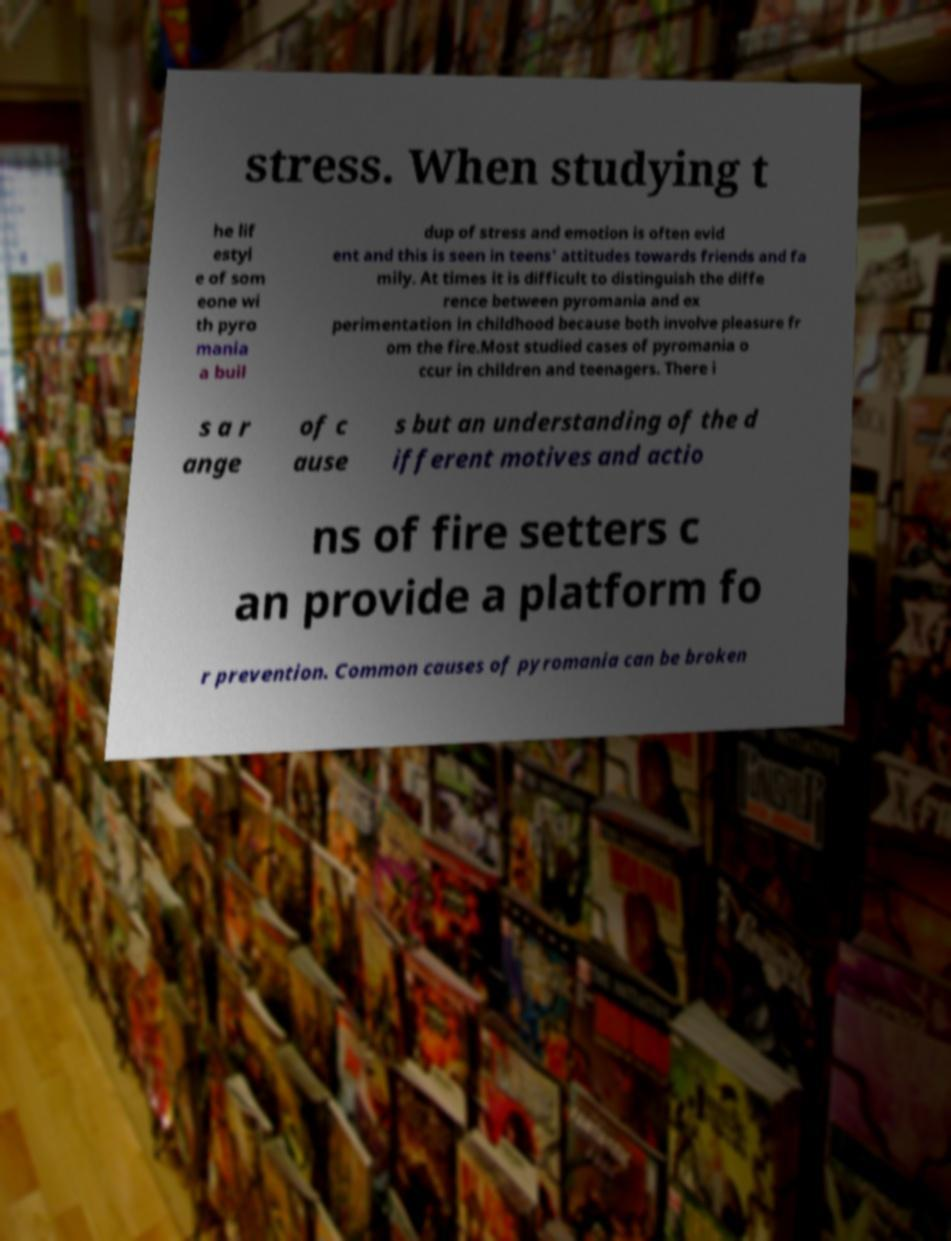For documentation purposes, I need the text within this image transcribed. Could you provide that? stress. When studying t he lif estyl e of som eone wi th pyro mania a buil dup of stress and emotion is often evid ent and this is seen in teens' attitudes towards friends and fa mily. At times it is difficult to distinguish the diffe rence between pyromania and ex perimentation in childhood because both involve pleasure fr om the fire.Most studied cases of pyromania o ccur in children and teenagers. There i s a r ange of c ause s but an understanding of the d ifferent motives and actio ns of fire setters c an provide a platform fo r prevention. Common causes of pyromania can be broken 